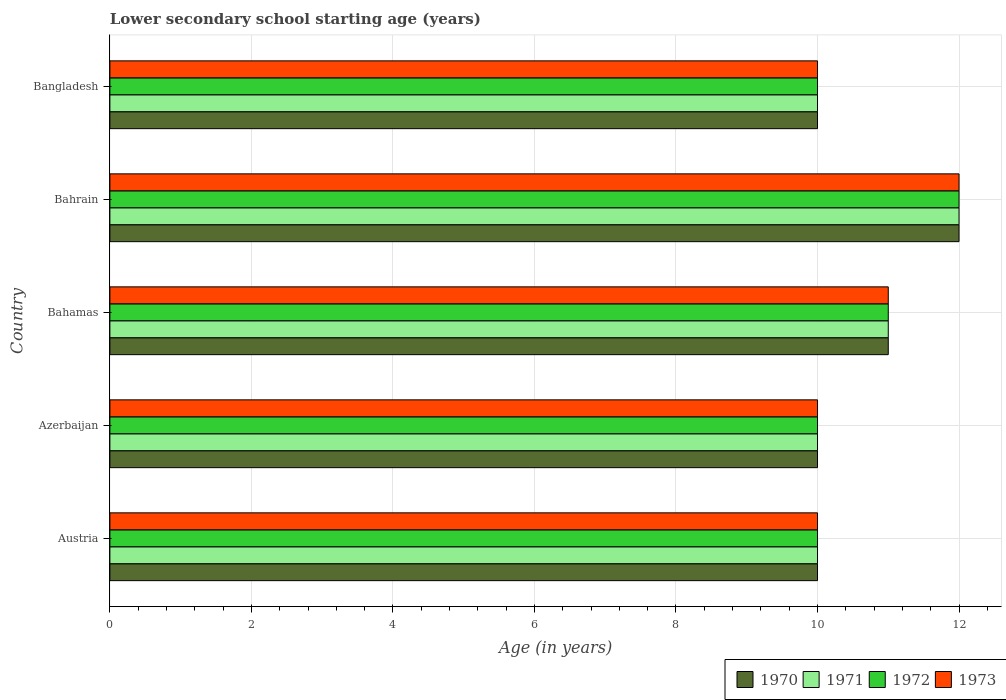How many different coloured bars are there?
Provide a succinct answer. 4. How many groups of bars are there?
Give a very brief answer. 5. Are the number of bars on each tick of the Y-axis equal?
Ensure brevity in your answer.  Yes. How many bars are there on the 2nd tick from the bottom?
Ensure brevity in your answer.  4. What is the label of the 4th group of bars from the top?
Ensure brevity in your answer.  Azerbaijan. What is the lower secondary school starting age of children in 1973 in Bahrain?
Offer a very short reply. 12. Across all countries, what is the maximum lower secondary school starting age of children in 1972?
Provide a succinct answer. 12. In which country was the lower secondary school starting age of children in 1971 maximum?
Provide a succinct answer. Bahrain. In which country was the lower secondary school starting age of children in 1972 minimum?
Offer a terse response. Austria. What is the difference between the lower secondary school starting age of children in 1971 in Austria and that in Bangladesh?
Your answer should be very brief. 0. What is the difference between the lower secondary school starting age of children in 1970 in Bahrain and the lower secondary school starting age of children in 1972 in Austria?
Offer a terse response. 2. What is the difference between the highest and the lowest lower secondary school starting age of children in 1972?
Offer a terse response. 2. Is the sum of the lower secondary school starting age of children in 1970 in Azerbaijan and Bahrain greater than the maximum lower secondary school starting age of children in 1971 across all countries?
Offer a terse response. Yes. What does the 3rd bar from the top in Austria represents?
Your response must be concise. 1971. Is it the case that in every country, the sum of the lower secondary school starting age of children in 1970 and lower secondary school starting age of children in 1971 is greater than the lower secondary school starting age of children in 1973?
Provide a succinct answer. Yes. Are all the bars in the graph horizontal?
Provide a short and direct response. Yes. What is the difference between two consecutive major ticks on the X-axis?
Ensure brevity in your answer.  2. Does the graph contain any zero values?
Provide a short and direct response. No. Does the graph contain grids?
Keep it short and to the point. Yes. Where does the legend appear in the graph?
Make the answer very short. Bottom right. How many legend labels are there?
Your response must be concise. 4. How are the legend labels stacked?
Keep it short and to the point. Horizontal. What is the title of the graph?
Give a very brief answer. Lower secondary school starting age (years). What is the label or title of the X-axis?
Your answer should be very brief. Age (in years). What is the label or title of the Y-axis?
Keep it short and to the point. Country. What is the Age (in years) in 1972 in Austria?
Your answer should be compact. 10. What is the Age (in years) of 1972 in Azerbaijan?
Provide a short and direct response. 10. What is the Age (in years) in 1973 in Azerbaijan?
Your response must be concise. 10. What is the Age (in years) of 1971 in Bahamas?
Make the answer very short. 11. What is the Age (in years) in 1972 in Bahamas?
Keep it short and to the point. 11. What is the Age (in years) of 1970 in Bahrain?
Your answer should be compact. 12. What is the Age (in years) in 1971 in Bangladesh?
Make the answer very short. 10. What is the Age (in years) of 1972 in Bangladesh?
Provide a short and direct response. 10. What is the Age (in years) of 1973 in Bangladesh?
Provide a short and direct response. 10. Across all countries, what is the minimum Age (in years) in 1970?
Give a very brief answer. 10. Across all countries, what is the minimum Age (in years) of 1971?
Offer a very short reply. 10. Across all countries, what is the minimum Age (in years) in 1973?
Offer a terse response. 10. What is the total Age (in years) of 1970 in the graph?
Make the answer very short. 53. What is the total Age (in years) of 1971 in the graph?
Offer a very short reply. 53. What is the total Age (in years) in 1973 in the graph?
Offer a terse response. 53. What is the difference between the Age (in years) of 1972 in Austria and that in Azerbaijan?
Offer a terse response. 0. What is the difference between the Age (in years) in 1973 in Austria and that in Azerbaijan?
Keep it short and to the point. 0. What is the difference between the Age (in years) of 1973 in Austria and that in Bahamas?
Ensure brevity in your answer.  -1. What is the difference between the Age (in years) in 1970 in Austria and that in Bahrain?
Keep it short and to the point. -2. What is the difference between the Age (in years) of 1972 in Austria and that in Bahrain?
Provide a succinct answer. -2. What is the difference between the Age (in years) of 1973 in Austria and that in Bahrain?
Offer a terse response. -2. What is the difference between the Age (in years) of 1971 in Austria and that in Bangladesh?
Give a very brief answer. 0. What is the difference between the Age (in years) of 1973 in Austria and that in Bangladesh?
Provide a short and direct response. 0. What is the difference between the Age (in years) of 1970 in Azerbaijan and that in Bahamas?
Offer a terse response. -1. What is the difference between the Age (in years) of 1973 in Azerbaijan and that in Bahamas?
Ensure brevity in your answer.  -1. What is the difference between the Age (in years) in 1972 in Azerbaijan and that in Bahrain?
Give a very brief answer. -2. What is the difference between the Age (in years) in 1972 in Azerbaijan and that in Bangladesh?
Provide a succinct answer. 0. What is the difference between the Age (in years) in 1973 in Azerbaijan and that in Bangladesh?
Provide a short and direct response. 0. What is the difference between the Age (in years) of 1970 in Bahamas and that in Bahrain?
Your answer should be compact. -1. What is the difference between the Age (in years) of 1972 in Bahamas and that in Bahrain?
Offer a terse response. -1. What is the difference between the Age (in years) of 1973 in Bahamas and that in Bahrain?
Make the answer very short. -1. What is the difference between the Age (in years) of 1971 in Bahamas and that in Bangladesh?
Offer a very short reply. 1. What is the difference between the Age (in years) in 1970 in Bahrain and that in Bangladesh?
Make the answer very short. 2. What is the difference between the Age (in years) of 1972 in Bahrain and that in Bangladesh?
Give a very brief answer. 2. What is the difference between the Age (in years) in 1973 in Bahrain and that in Bangladesh?
Provide a succinct answer. 2. What is the difference between the Age (in years) in 1970 in Austria and the Age (in years) in 1973 in Azerbaijan?
Your response must be concise. 0. What is the difference between the Age (in years) of 1970 in Austria and the Age (in years) of 1972 in Bahamas?
Ensure brevity in your answer.  -1. What is the difference between the Age (in years) in 1970 in Austria and the Age (in years) in 1973 in Bahamas?
Provide a short and direct response. -1. What is the difference between the Age (in years) of 1970 in Austria and the Age (in years) of 1971 in Bahrain?
Provide a succinct answer. -2. What is the difference between the Age (in years) in 1970 in Austria and the Age (in years) in 1972 in Bahrain?
Offer a terse response. -2. What is the difference between the Age (in years) in 1971 in Austria and the Age (in years) in 1973 in Bahrain?
Provide a short and direct response. -2. What is the difference between the Age (in years) of 1970 in Austria and the Age (in years) of 1971 in Bangladesh?
Your answer should be compact. 0. What is the difference between the Age (in years) in 1970 in Austria and the Age (in years) in 1972 in Bangladesh?
Keep it short and to the point. 0. What is the difference between the Age (in years) of 1970 in Austria and the Age (in years) of 1973 in Bangladesh?
Your answer should be very brief. 0. What is the difference between the Age (in years) in 1971 in Austria and the Age (in years) in 1973 in Bangladesh?
Provide a succinct answer. 0. What is the difference between the Age (in years) of 1972 in Austria and the Age (in years) of 1973 in Bangladesh?
Keep it short and to the point. 0. What is the difference between the Age (in years) in 1970 in Azerbaijan and the Age (in years) in 1972 in Bahamas?
Provide a short and direct response. -1. What is the difference between the Age (in years) of 1970 in Azerbaijan and the Age (in years) of 1973 in Bahamas?
Your answer should be compact. -1. What is the difference between the Age (in years) in 1972 in Azerbaijan and the Age (in years) in 1973 in Bahamas?
Your answer should be very brief. -1. What is the difference between the Age (in years) of 1970 in Azerbaijan and the Age (in years) of 1971 in Bahrain?
Your answer should be compact. -2. What is the difference between the Age (in years) of 1971 in Azerbaijan and the Age (in years) of 1973 in Bahrain?
Keep it short and to the point. -2. What is the difference between the Age (in years) of 1972 in Azerbaijan and the Age (in years) of 1973 in Bahrain?
Keep it short and to the point. -2. What is the difference between the Age (in years) in 1970 in Azerbaijan and the Age (in years) in 1971 in Bangladesh?
Provide a succinct answer. 0. What is the difference between the Age (in years) of 1970 in Azerbaijan and the Age (in years) of 1972 in Bangladesh?
Provide a short and direct response. 0. What is the difference between the Age (in years) of 1970 in Azerbaijan and the Age (in years) of 1973 in Bangladesh?
Your response must be concise. 0. What is the difference between the Age (in years) of 1971 in Azerbaijan and the Age (in years) of 1972 in Bangladesh?
Offer a terse response. 0. What is the difference between the Age (in years) of 1971 in Azerbaijan and the Age (in years) of 1973 in Bangladesh?
Provide a short and direct response. 0. What is the difference between the Age (in years) of 1972 in Azerbaijan and the Age (in years) of 1973 in Bangladesh?
Give a very brief answer. 0. What is the difference between the Age (in years) in 1970 in Bahamas and the Age (in years) in 1972 in Bahrain?
Give a very brief answer. -1. What is the difference between the Age (in years) in 1970 in Bahamas and the Age (in years) in 1973 in Bahrain?
Your answer should be very brief. -1. What is the difference between the Age (in years) in 1971 in Bahamas and the Age (in years) in 1973 in Bahrain?
Offer a terse response. -1. What is the difference between the Age (in years) of 1972 in Bahamas and the Age (in years) of 1973 in Bahrain?
Provide a short and direct response. -1. What is the difference between the Age (in years) of 1970 in Bahrain and the Age (in years) of 1973 in Bangladesh?
Provide a succinct answer. 2. What is the difference between the Age (in years) of 1972 in Bahrain and the Age (in years) of 1973 in Bangladesh?
Make the answer very short. 2. What is the average Age (in years) in 1970 per country?
Offer a very short reply. 10.6. What is the average Age (in years) in 1973 per country?
Provide a short and direct response. 10.6. What is the difference between the Age (in years) of 1970 and Age (in years) of 1972 in Austria?
Your response must be concise. 0. What is the difference between the Age (in years) of 1970 and Age (in years) of 1973 in Austria?
Provide a succinct answer. 0. What is the difference between the Age (in years) in 1971 and Age (in years) in 1973 in Austria?
Offer a very short reply. 0. What is the difference between the Age (in years) in 1970 and Age (in years) in 1971 in Azerbaijan?
Offer a terse response. 0. What is the difference between the Age (in years) of 1970 and Age (in years) of 1972 in Azerbaijan?
Make the answer very short. 0. What is the difference between the Age (in years) in 1970 and Age (in years) in 1973 in Azerbaijan?
Your response must be concise. 0. What is the difference between the Age (in years) of 1972 and Age (in years) of 1973 in Azerbaijan?
Ensure brevity in your answer.  0. What is the difference between the Age (in years) in 1970 and Age (in years) in 1972 in Bahamas?
Keep it short and to the point. 0. What is the difference between the Age (in years) of 1970 and Age (in years) of 1973 in Bahamas?
Your response must be concise. 0. What is the difference between the Age (in years) in 1971 and Age (in years) in 1972 in Bahamas?
Give a very brief answer. 0. What is the difference between the Age (in years) in 1971 and Age (in years) in 1973 in Bahamas?
Keep it short and to the point. 0. What is the difference between the Age (in years) of 1972 and Age (in years) of 1973 in Bahamas?
Your response must be concise. 0. What is the difference between the Age (in years) in 1970 and Age (in years) in 1971 in Bahrain?
Provide a succinct answer. 0. What is the difference between the Age (in years) of 1971 and Age (in years) of 1972 in Bahrain?
Make the answer very short. 0. What is the difference between the Age (in years) in 1971 and Age (in years) in 1973 in Bahrain?
Offer a terse response. 0. What is the difference between the Age (in years) in 1971 and Age (in years) in 1973 in Bangladesh?
Offer a terse response. 0. What is the difference between the Age (in years) of 1972 and Age (in years) of 1973 in Bangladesh?
Keep it short and to the point. 0. What is the ratio of the Age (in years) of 1971 in Austria to that in Azerbaijan?
Your answer should be very brief. 1. What is the ratio of the Age (in years) of 1970 in Austria to that in Bahamas?
Keep it short and to the point. 0.91. What is the ratio of the Age (in years) of 1970 in Austria to that in Bahrain?
Your response must be concise. 0.83. What is the ratio of the Age (in years) in 1972 in Austria to that in Bahrain?
Offer a very short reply. 0.83. What is the ratio of the Age (in years) of 1970 in Austria to that in Bangladesh?
Keep it short and to the point. 1. What is the ratio of the Age (in years) of 1973 in Austria to that in Bangladesh?
Your answer should be compact. 1. What is the ratio of the Age (in years) in 1970 in Azerbaijan to that in Bahamas?
Make the answer very short. 0.91. What is the ratio of the Age (in years) of 1972 in Azerbaijan to that in Bahamas?
Provide a short and direct response. 0.91. What is the ratio of the Age (in years) in 1973 in Azerbaijan to that in Bahamas?
Your response must be concise. 0.91. What is the ratio of the Age (in years) in 1971 in Azerbaijan to that in Bahrain?
Make the answer very short. 0.83. What is the ratio of the Age (in years) in 1972 in Azerbaijan to that in Bahrain?
Offer a terse response. 0.83. What is the ratio of the Age (in years) of 1971 in Azerbaijan to that in Bangladesh?
Provide a succinct answer. 1. What is the ratio of the Age (in years) in 1972 in Azerbaijan to that in Bangladesh?
Your answer should be compact. 1. What is the ratio of the Age (in years) in 1970 in Bahamas to that in Bahrain?
Ensure brevity in your answer.  0.92. What is the ratio of the Age (in years) of 1972 in Bahamas to that in Bahrain?
Make the answer very short. 0.92. What is the ratio of the Age (in years) in 1973 in Bahamas to that in Bahrain?
Keep it short and to the point. 0.92. What is the ratio of the Age (in years) of 1971 in Bahamas to that in Bangladesh?
Make the answer very short. 1.1. What is the ratio of the Age (in years) of 1971 in Bahrain to that in Bangladesh?
Provide a short and direct response. 1.2. What is the ratio of the Age (in years) in 1972 in Bahrain to that in Bangladesh?
Provide a short and direct response. 1.2. What is the difference between the highest and the second highest Age (in years) of 1970?
Your answer should be very brief. 1. What is the difference between the highest and the second highest Age (in years) in 1971?
Ensure brevity in your answer.  1. What is the difference between the highest and the lowest Age (in years) in 1973?
Give a very brief answer. 2. 